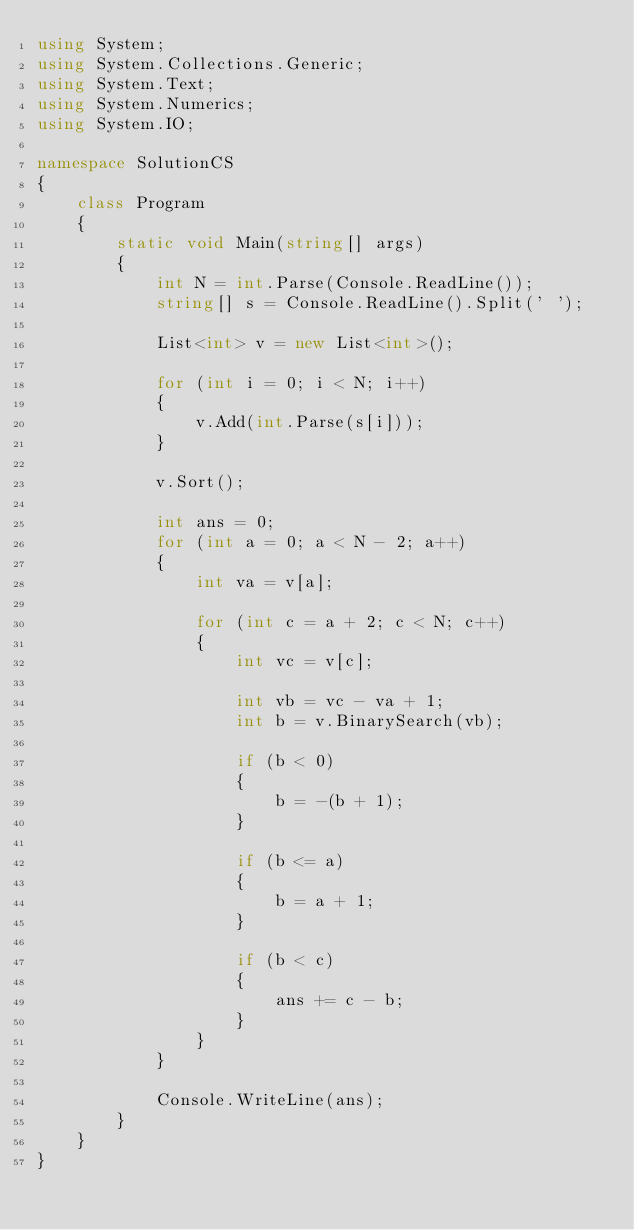Convert code to text. <code><loc_0><loc_0><loc_500><loc_500><_C#_>using System;
using System.Collections.Generic;
using System.Text;
using System.Numerics;
using System.IO;

namespace SolutionCS
{
    class Program
    {
        static void Main(string[] args)
        {
            int N = int.Parse(Console.ReadLine());
            string[] s = Console.ReadLine().Split(' ');

            List<int> v = new List<int>();

            for (int i = 0; i < N; i++)
            {
                v.Add(int.Parse(s[i]));
            }

            v.Sort();

            int ans = 0;
            for (int a = 0; a < N - 2; a++)
            {
                int va = v[a];

                for (int c = a + 2; c < N; c++)
                {
                    int vc = v[c];

                    int vb = vc - va + 1;
                    int b = v.BinarySearch(vb);

                    if (b < 0)
                    {
                        b = -(b + 1);
                    }

                    if (b <= a)
                    {
                        b = a + 1;
                    }

                    if (b < c)
                    {
                        ans += c - b;
                    }
                }
            }

            Console.WriteLine(ans);
        }
    }
}

</code> 